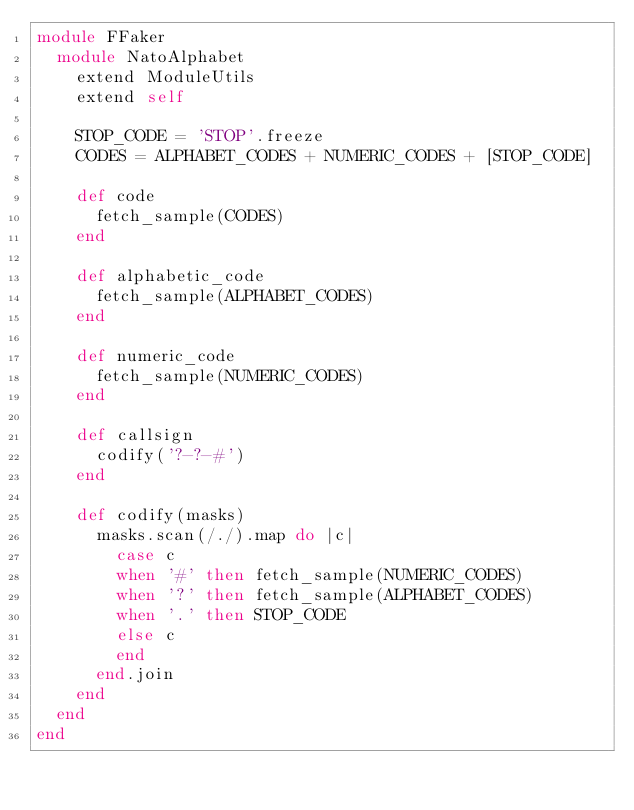<code> <loc_0><loc_0><loc_500><loc_500><_Ruby_>module FFaker
  module NatoAlphabet
    extend ModuleUtils
    extend self

    STOP_CODE = 'STOP'.freeze
    CODES = ALPHABET_CODES + NUMERIC_CODES + [STOP_CODE]

    def code
      fetch_sample(CODES)
    end

    def alphabetic_code
      fetch_sample(ALPHABET_CODES)
    end

    def numeric_code
      fetch_sample(NUMERIC_CODES)
    end

    def callsign
      codify('?-?-#')
    end

    def codify(masks)
      masks.scan(/./).map do |c|
        case c
        when '#' then fetch_sample(NUMERIC_CODES)
        when '?' then fetch_sample(ALPHABET_CODES)
        when '.' then STOP_CODE
        else c
        end
      end.join
    end
  end
end
</code> 